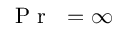Convert formula to latex. <formula><loc_0><loc_0><loc_500><loc_500>{ P r } = \infty</formula> 